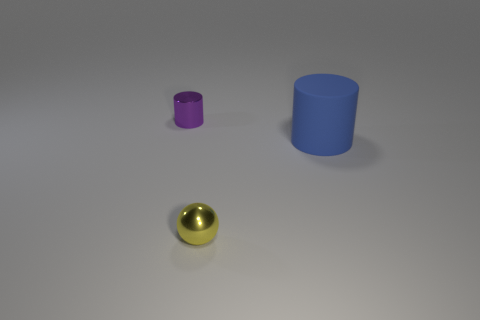What number of objects are both behind the yellow metal ball and on the left side of the big rubber object?
Your answer should be very brief. 1. The large object has what color?
Your response must be concise. Blue. What is the material of the purple thing that is the same shape as the blue thing?
Your response must be concise. Metal. Is there any other thing that has the same material as the small cylinder?
Keep it short and to the point. Yes. Do the shiny sphere and the metallic cylinder have the same color?
Your answer should be very brief. No. What shape is the small metal thing that is behind the object right of the small yellow ball?
Your answer should be very brief. Cylinder. What shape is the purple object that is made of the same material as the ball?
Give a very brief answer. Cylinder. What number of other things are there of the same shape as the yellow metallic thing?
Offer a terse response. 0. There is a cylinder to the right of the metal cylinder; does it have the same size as the tiny yellow shiny sphere?
Your answer should be very brief. No. Is the number of purple cylinders that are behind the rubber object greater than the number of gray metallic blocks?
Your answer should be compact. Yes. 